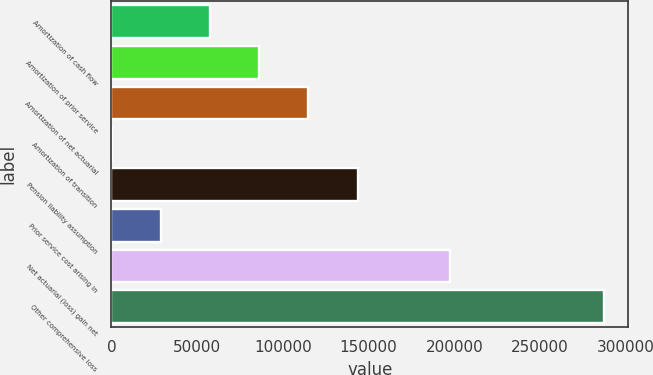<chart> <loc_0><loc_0><loc_500><loc_500><bar_chart><fcel>Amortization of cash flow<fcel>Amortization of prior service<fcel>Amortization of net actuarial<fcel>Amortization of transition<fcel>Pension liability assumption<fcel>Prior service cost arising in<fcel>Net actuarial (loss) gain net<fcel>Other comprehensive loss<nl><fcel>57521.2<fcel>86205.3<fcel>114889<fcel>153<fcel>143574<fcel>28837.1<fcel>197604<fcel>286994<nl></chart> 